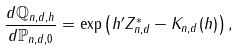<formula> <loc_0><loc_0><loc_500><loc_500>\frac { d \mathbb { Q } _ { n , d , h } } { d \mathbb { P } _ { n , d , 0 } } = \exp \left ( h ^ { \prime } Z ^ { * } _ { n , d } - K _ { n , d } ( h ) \right ) ,</formula> 